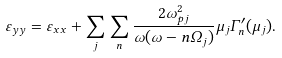Convert formula to latex. <formula><loc_0><loc_0><loc_500><loc_500>\varepsilon _ { y y } = \varepsilon _ { x x } + \sum _ { j } \sum _ { n } \frac { 2 \omega _ { p j } ^ { 2 } } { \omega ( \omega - n \Omega _ { j } ) } \mu _ { j } \Gamma ^ { \prime } _ { n } ( \mu _ { j } ) .</formula> 